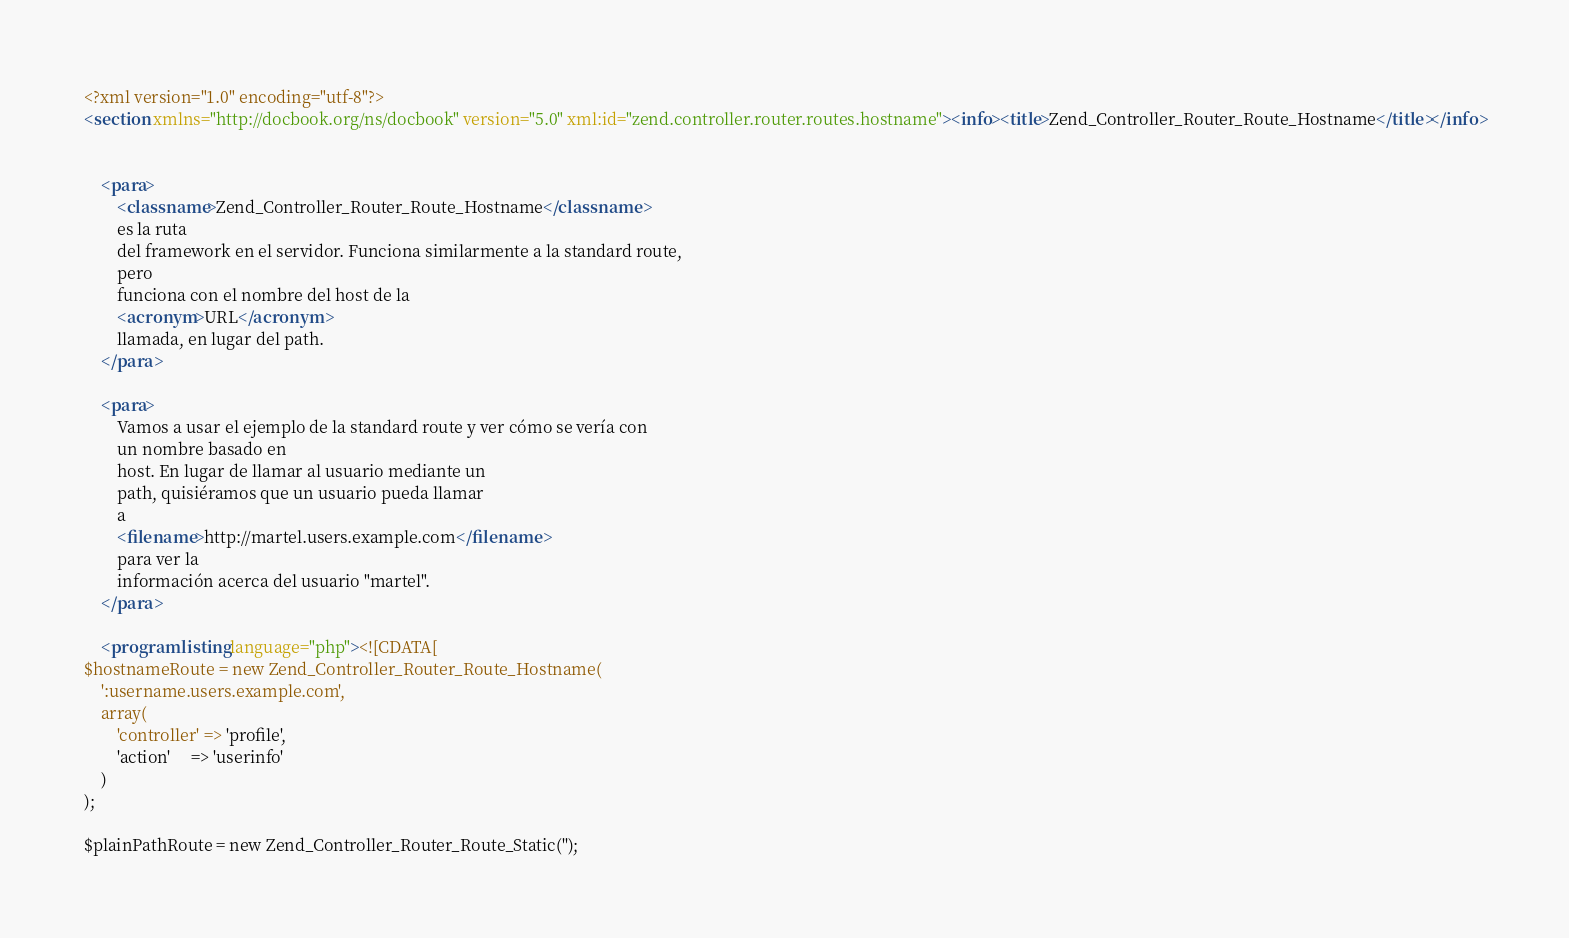<code> <loc_0><loc_0><loc_500><loc_500><_XML_><?xml version="1.0" encoding="utf-8"?>
<section xmlns="http://docbook.org/ns/docbook" version="5.0" xml:id="zend.controller.router.routes.hostname"><info><title>Zend_Controller_Router_Route_Hostname</title></info>
    

    <para>
        <classname>Zend_Controller_Router_Route_Hostname</classname>
        es la ruta
        del framework en el servidor. Funciona similarmente a la standard route,
        pero
        funciona con el nombre del host de la
        <acronym>URL</acronym>
        llamada, en lugar del path.
    </para>

    <para>
        Vamos a usar el ejemplo de la standard route y ver cómo se vería con
        un nombre basado en
        host. En lugar de llamar al usuario mediante un
        path, quisiéramos que un usuario pueda llamar
        a
        <filename>http://martel.users.example.com</filename>
        para ver la
        información acerca del usuario "martel".
    </para>

    <programlisting language="php"><![CDATA[
$hostnameRoute = new Zend_Controller_Router_Route_Hostname(
    ':username.users.example.com',
    array(
        'controller' => 'profile',
        'action'     => 'userinfo'
    )
);

$plainPathRoute = new Zend_Controller_Router_Route_Static('');
</code> 